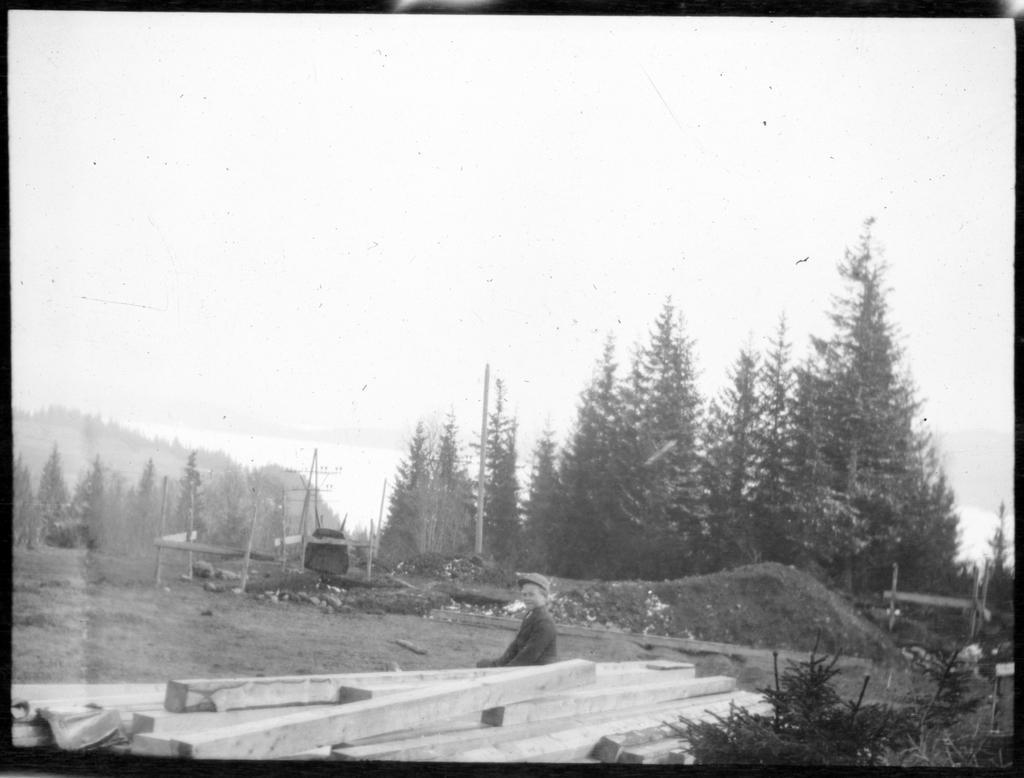Please provide a concise description of this image. In this image a person is sitting behind the wooden planks. He is wearing a cap. Left side there are few poles on the grassland. Right bottom there are few plants. Background there are few trees. Top of the image there is sky. 